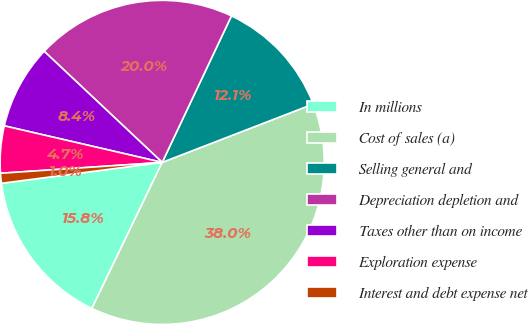Convert chart. <chart><loc_0><loc_0><loc_500><loc_500><pie_chart><fcel>In millions<fcel>Cost of sales (a)<fcel>Selling general and<fcel>Depreciation depletion and<fcel>Taxes other than on income<fcel>Exploration expense<fcel>Interest and debt expense net<nl><fcel>15.8%<fcel>38.01%<fcel>12.1%<fcel>20.01%<fcel>8.4%<fcel>4.69%<fcel>0.99%<nl></chart> 